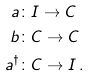Convert formula to latex. <formula><loc_0><loc_0><loc_500><loc_500>a \colon & I \to C \\ b \colon & C \to C \\ a ^ { \dagger } \colon & C \to I \, .</formula> 